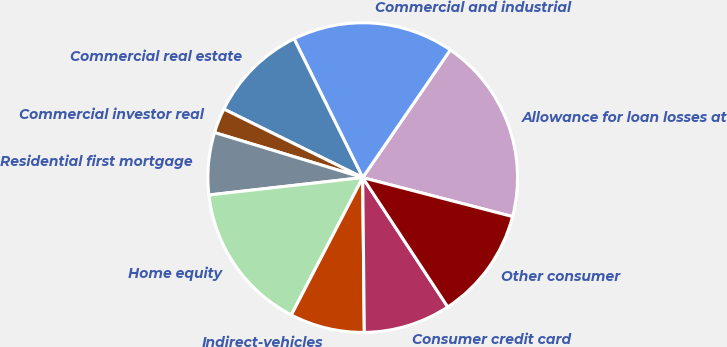Convert chart to OTSL. <chart><loc_0><loc_0><loc_500><loc_500><pie_chart><fcel>Allowance for loan losses at<fcel>Commercial and industrial<fcel>Commercial real estate<fcel>Commercial investor real<fcel>Residential first mortgage<fcel>Home equity<fcel>Indirect-vehicles<fcel>Consumer credit card<fcel>Other consumer<nl><fcel>19.48%<fcel>16.88%<fcel>10.39%<fcel>2.6%<fcel>6.49%<fcel>15.58%<fcel>7.79%<fcel>9.09%<fcel>11.69%<nl></chart> 